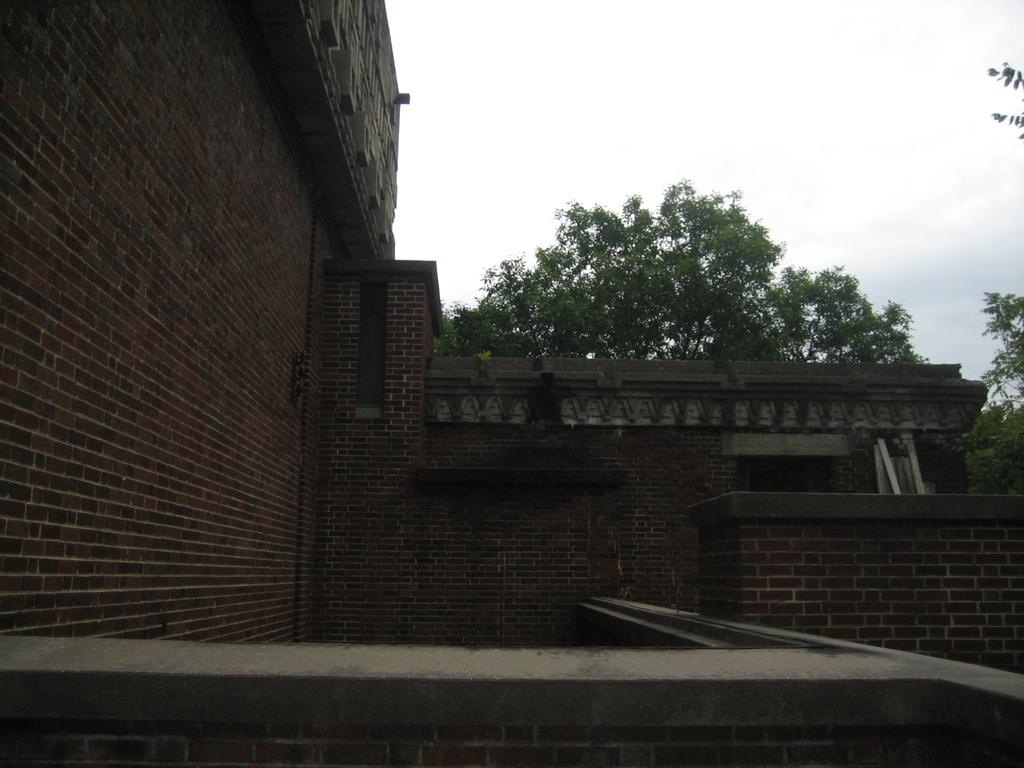What type of structures can be seen in the image? There are buildings in the image. What type of vegetation is present in the image? There are trees in the image. What type of riddle is being solved by the plants in the image? There are no plants or riddles present in the image. What type of apparel is being worn by the trees in the image? There are no trees or apparel present in the image. 